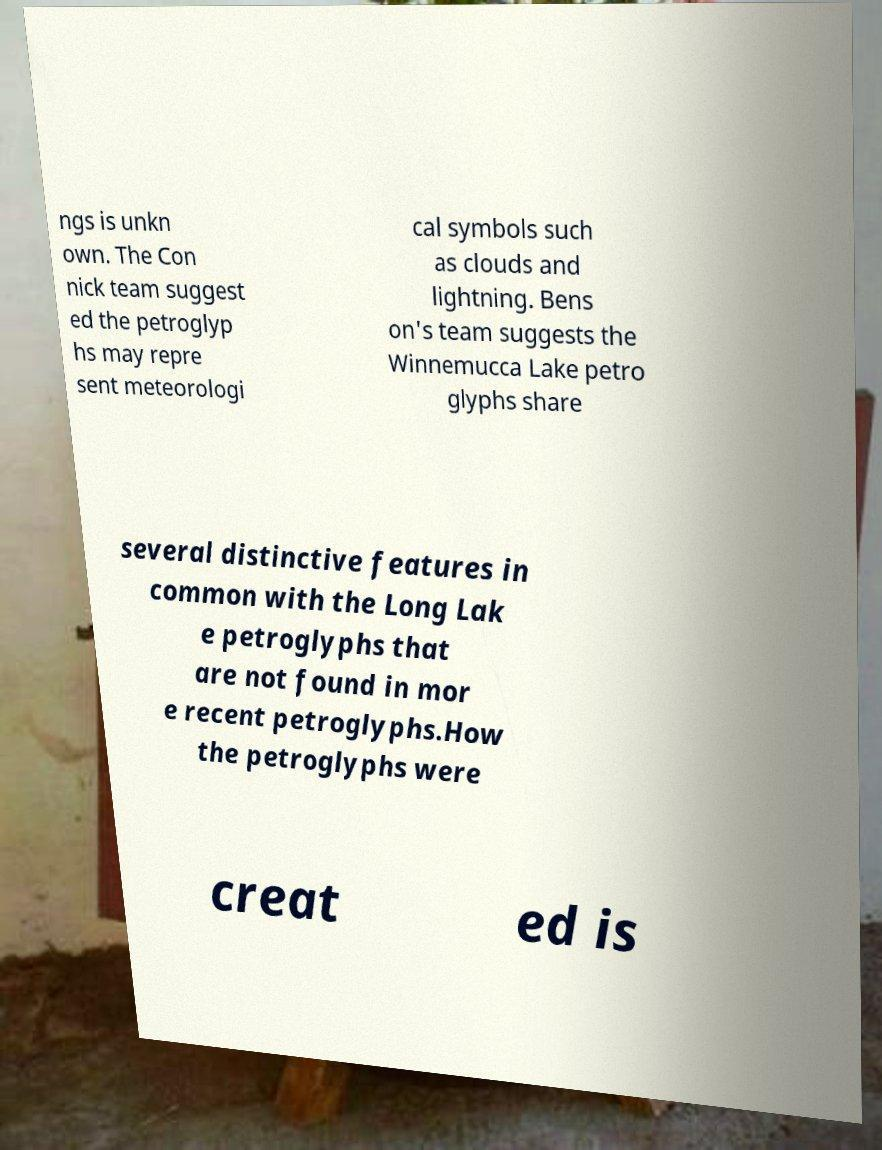Can you accurately transcribe the text from the provided image for me? ngs is unkn own. The Con nick team suggest ed the petroglyp hs may repre sent meteorologi cal symbols such as clouds and lightning. Bens on's team suggests the Winnemucca Lake petro glyphs share several distinctive features in common with the Long Lak e petroglyphs that are not found in mor e recent petroglyphs.How the petroglyphs were creat ed is 